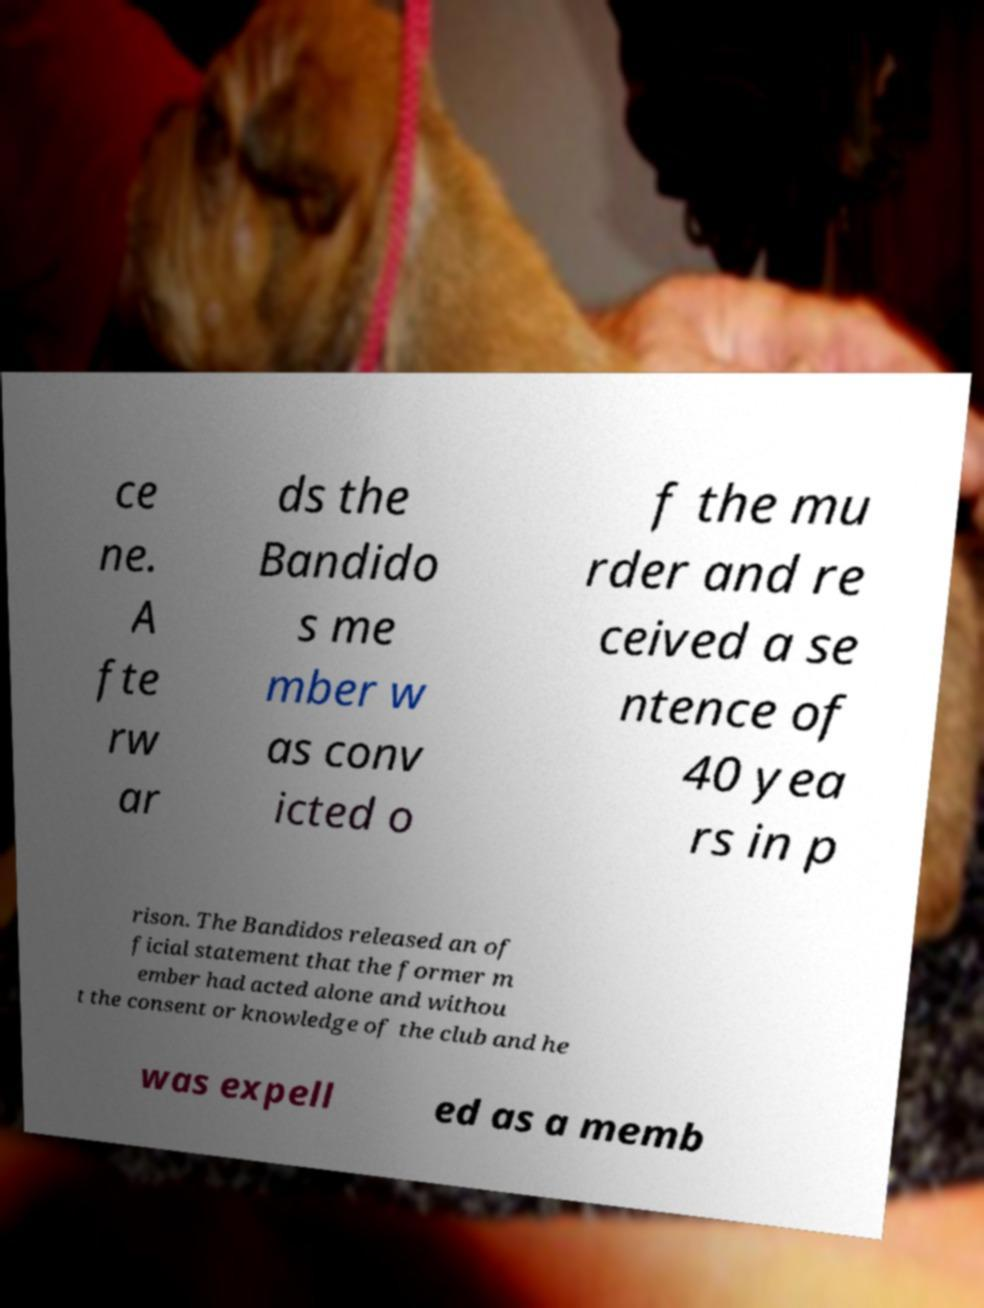What messages or text are displayed in this image? I need them in a readable, typed format. ce ne. A fte rw ar ds the Bandido s me mber w as conv icted o f the mu rder and re ceived a se ntence of 40 yea rs in p rison. The Bandidos released an of ficial statement that the former m ember had acted alone and withou t the consent or knowledge of the club and he was expell ed as a memb 